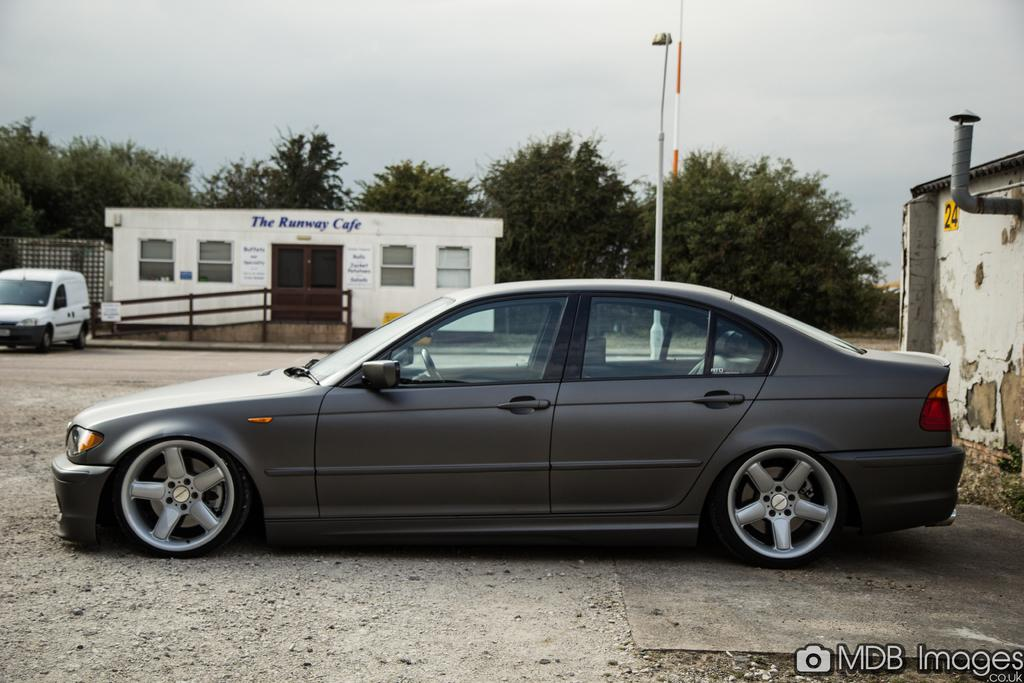What structures are present in the image? There are poles in the image. What type of vehicles can be seen in the image? There are cars in the image. What type of buildings are visible in the image? There are houses in the image. What else is present on these structures in the image? There are posters in the image. What type of vegetation is visible in the image? There are trees in the image. What is visible in the background of the image? The sky is visible in the background of the image. Where are the chairs located in the image? There are no chairs present in the image. What type of toys can be seen in the image? There are no toys present in the image. 